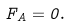<formula> <loc_0><loc_0><loc_500><loc_500>F _ { A } = 0 .</formula> 